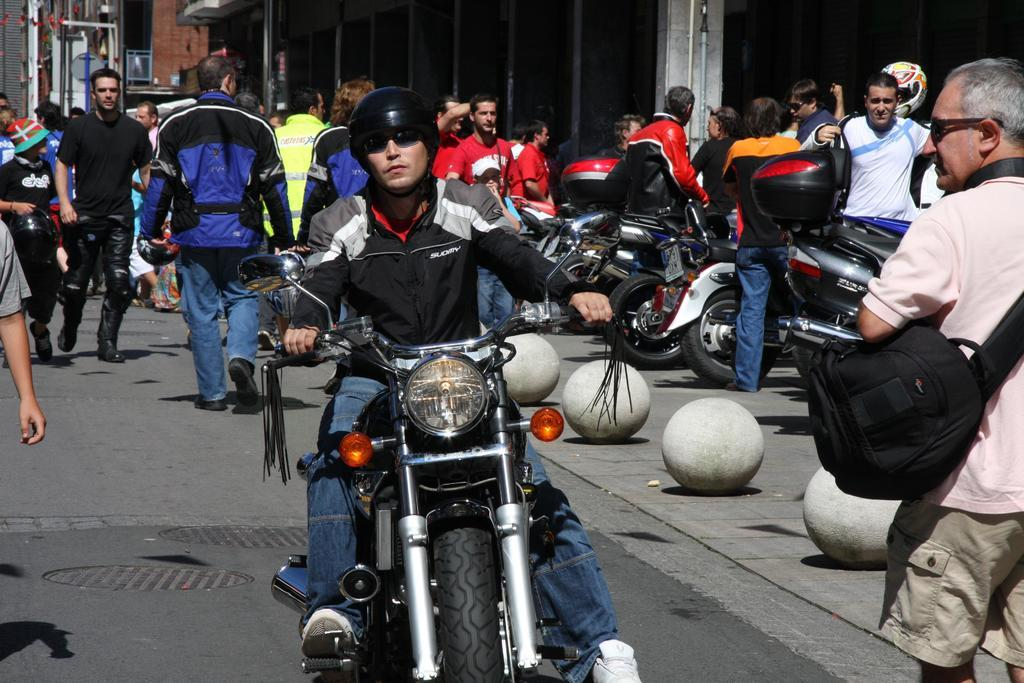How many people are in the image? There is a group of persons in the image. What are the persons in the image doing? The persons are standing. Can you describe the person wearing a black color jacket and helmet in the image? The person is wearing a black color jacket and helmet, and they are riding a motorcycle. Where is the motorcycle located in the image? The motorcycle is in the middle of the image. What type of pain is the person on the motorcycle experiencing in the image? There is no indication in the image that the person on the motorcycle is experiencing any pain. Can you tell me how many spoons are visible in the image? There are no spoons present in the image. 